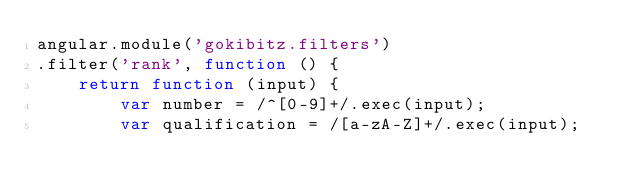Convert code to text. <code><loc_0><loc_0><loc_500><loc_500><_JavaScript_>angular.module('gokibitz.filters')
.filter('rank', function () {
	return function (input) {
		var number = /^[0-9]+/.exec(input);
		var qualification = /[a-zA-Z]+/.exec(input);
</code> 